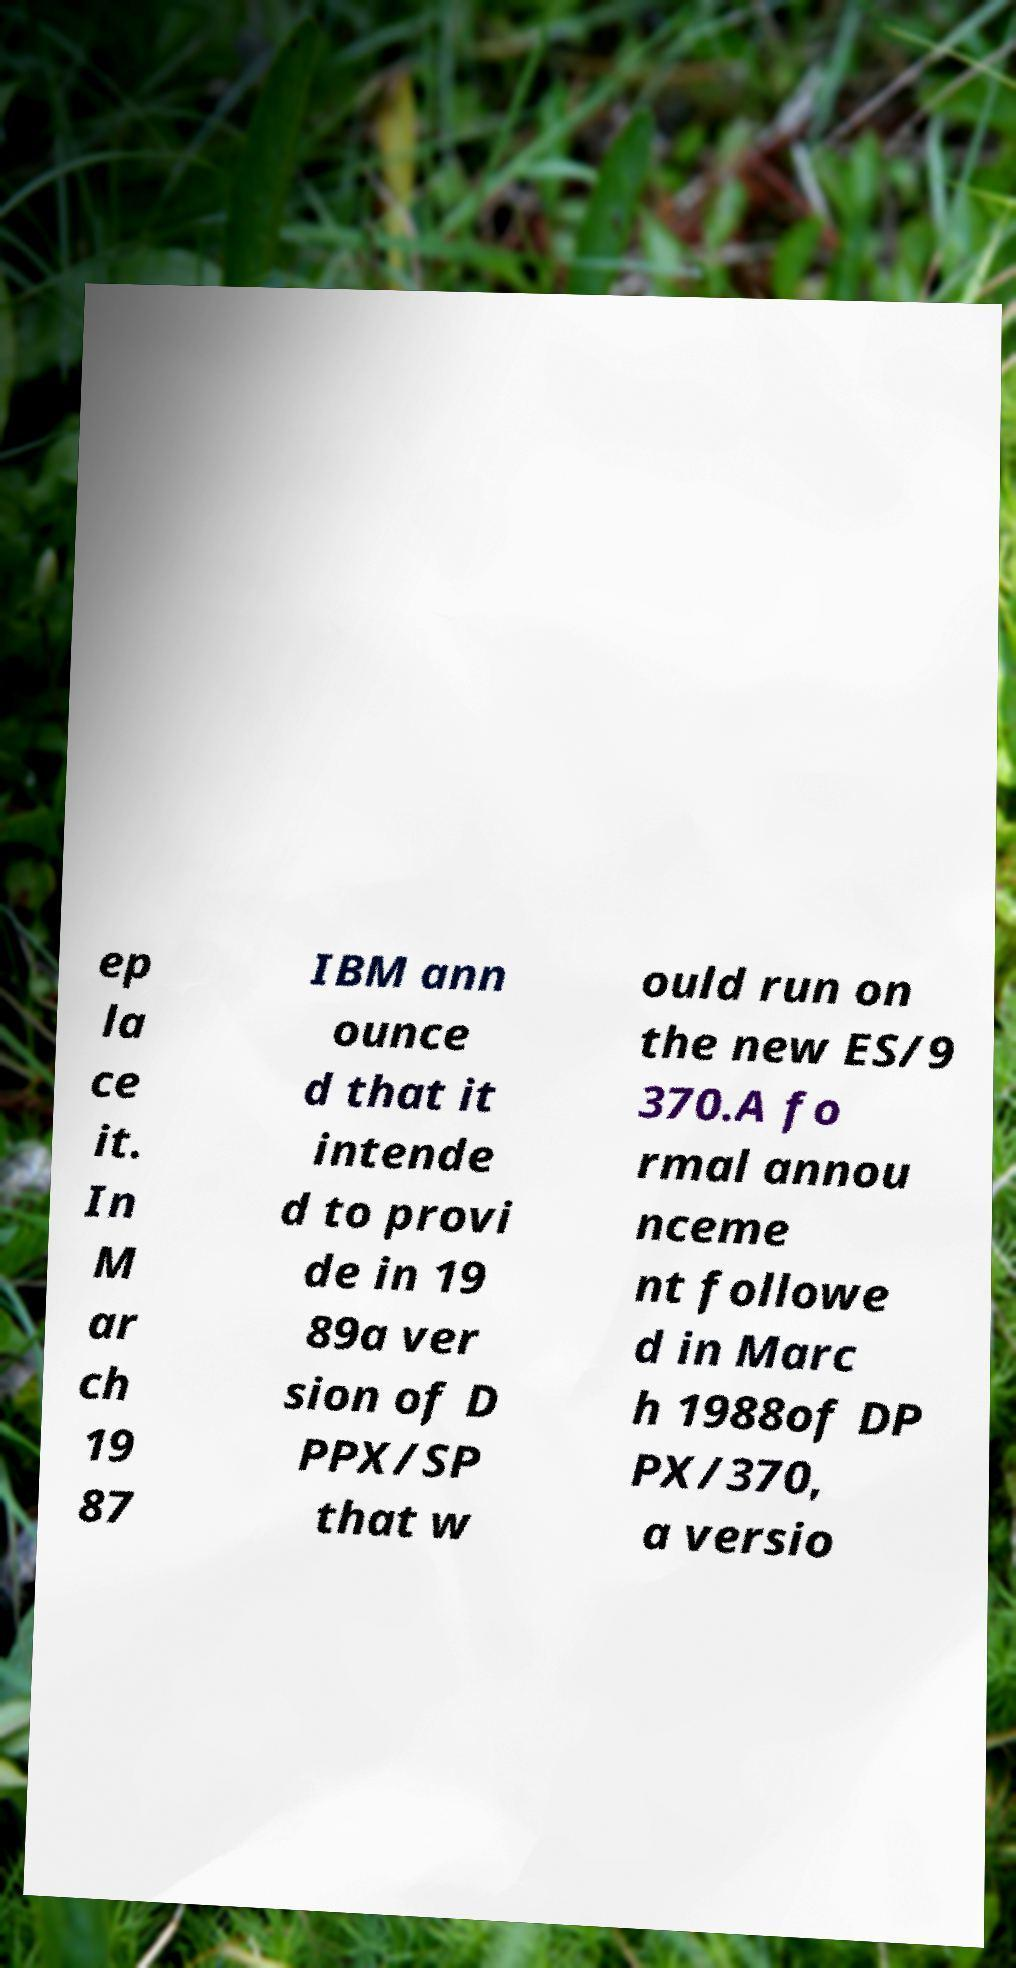Please identify and transcribe the text found in this image. ep la ce it. In M ar ch 19 87 IBM ann ounce d that it intende d to provi de in 19 89a ver sion of D PPX/SP that w ould run on the new ES/9 370.A fo rmal annou nceme nt followe d in Marc h 1988of DP PX/370, a versio 